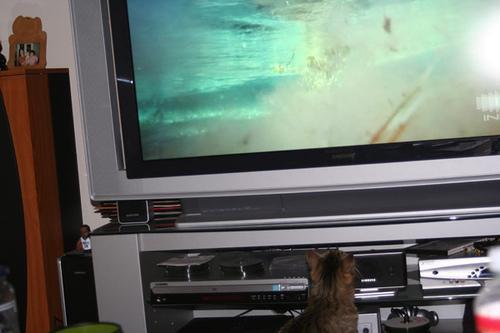How many people commonly use this bathroom?
Give a very brief answer. 0. 